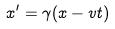Convert formula to latex. <formula><loc_0><loc_0><loc_500><loc_500>x ^ { \prime } = \gamma ( x - v t )</formula> 